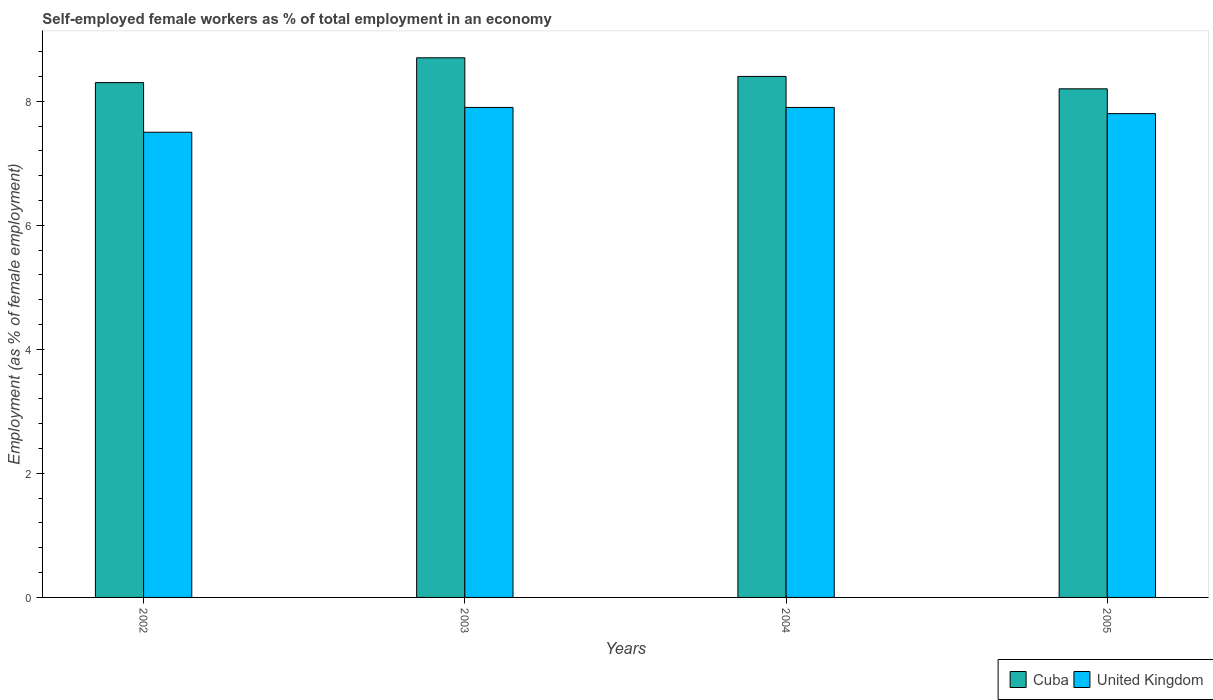How many groups of bars are there?
Your response must be concise. 4. Are the number of bars per tick equal to the number of legend labels?
Your answer should be compact. Yes. Are the number of bars on each tick of the X-axis equal?
Your answer should be compact. Yes. How many bars are there on the 2nd tick from the left?
Your response must be concise. 2. How many bars are there on the 1st tick from the right?
Offer a terse response. 2. In how many cases, is the number of bars for a given year not equal to the number of legend labels?
Give a very brief answer. 0. What is the percentage of self-employed female workers in Cuba in 2005?
Ensure brevity in your answer.  8.2. Across all years, what is the maximum percentage of self-employed female workers in United Kingdom?
Give a very brief answer. 7.9. In which year was the percentage of self-employed female workers in United Kingdom minimum?
Ensure brevity in your answer.  2002. What is the total percentage of self-employed female workers in Cuba in the graph?
Offer a terse response. 33.6. What is the difference between the percentage of self-employed female workers in United Kingdom in 2002 and that in 2005?
Provide a short and direct response. -0.3. What is the difference between the percentage of self-employed female workers in Cuba in 2002 and the percentage of self-employed female workers in United Kingdom in 2004?
Offer a very short reply. 0.4. What is the average percentage of self-employed female workers in Cuba per year?
Offer a very short reply. 8.4. In the year 2005, what is the difference between the percentage of self-employed female workers in United Kingdom and percentage of self-employed female workers in Cuba?
Your response must be concise. -0.4. What is the ratio of the percentage of self-employed female workers in United Kingdom in 2003 to that in 2005?
Keep it short and to the point. 1.01. Is the difference between the percentage of self-employed female workers in United Kingdom in 2004 and 2005 greater than the difference between the percentage of self-employed female workers in Cuba in 2004 and 2005?
Offer a very short reply. No. What is the difference between the highest and the second highest percentage of self-employed female workers in United Kingdom?
Ensure brevity in your answer.  0. Is the sum of the percentage of self-employed female workers in Cuba in 2002 and 2004 greater than the maximum percentage of self-employed female workers in United Kingdom across all years?
Offer a very short reply. Yes. What does the 2nd bar from the right in 2004 represents?
Offer a very short reply. Cuba. Are all the bars in the graph horizontal?
Make the answer very short. No. How many years are there in the graph?
Keep it short and to the point. 4. Are the values on the major ticks of Y-axis written in scientific E-notation?
Offer a very short reply. No. Does the graph contain grids?
Give a very brief answer. No. Where does the legend appear in the graph?
Offer a very short reply. Bottom right. How many legend labels are there?
Offer a very short reply. 2. What is the title of the graph?
Keep it short and to the point. Self-employed female workers as % of total employment in an economy. Does "Antigua and Barbuda" appear as one of the legend labels in the graph?
Your answer should be very brief. No. What is the label or title of the X-axis?
Ensure brevity in your answer.  Years. What is the label or title of the Y-axis?
Offer a terse response. Employment (as % of female employment). What is the Employment (as % of female employment) of Cuba in 2002?
Ensure brevity in your answer.  8.3. What is the Employment (as % of female employment) of Cuba in 2003?
Your response must be concise. 8.7. What is the Employment (as % of female employment) in United Kingdom in 2003?
Offer a very short reply. 7.9. What is the Employment (as % of female employment) in Cuba in 2004?
Provide a succinct answer. 8.4. What is the Employment (as % of female employment) in United Kingdom in 2004?
Your answer should be very brief. 7.9. What is the Employment (as % of female employment) in Cuba in 2005?
Keep it short and to the point. 8.2. What is the Employment (as % of female employment) of United Kingdom in 2005?
Keep it short and to the point. 7.8. Across all years, what is the maximum Employment (as % of female employment) of Cuba?
Your answer should be very brief. 8.7. Across all years, what is the maximum Employment (as % of female employment) of United Kingdom?
Your answer should be very brief. 7.9. Across all years, what is the minimum Employment (as % of female employment) of Cuba?
Provide a succinct answer. 8.2. What is the total Employment (as % of female employment) of Cuba in the graph?
Your response must be concise. 33.6. What is the total Employment (as % of female employment) in United Kingdom in the graph?
Offer a terse response. 31.1. What is the difference between the Employment (as % of female employment) of Cuba in 2002 and that in 2005?
Offer a very short reply. 0.1. What is the difference between the Employment (as % of female employment) in United Kingdom in 2003 and that in 2004?
Give a very brief answer. 0. What is the difference between the Employment (as % of female employment) of United Kingdom in 2003 and that in 2005?
Provide a short and direct response. 0.1. What is the difference between the Employment (as % of female employment) in Cuba in 2002 and the Employment (as % of female employment) in United Kingdom in 2003?
Provide a short and direct response. 0.4. What is the difference between the Employment (as % of female employment) in Cuba in 2002 and the Employment (as % of female employment) in United Kingdom in 2004?
Make the answer very short. 0.4. What is the difference between the Employment (as % of female employment) in Cuba in 2002 and the Employment (as % of female employment) in United Kingdom in 2005?
Give a very brief answer. 0.5. What is the difference between the Employment (as % of female employment) in Cuba in 2003 and the Employment (as % of female employment) in United Kingdom in 2005?
Provide a short and direct response. 0.9. What is the average Employment (as % of female employment) in United Kingdom per year?
Provide a short and direct response. 7.78. In the year 2002, what is the difference between the Employment (as % of female employment) in Cuba and Employment (as % of female employment) in United Kingdom?
Your response must be concise. 0.8. In the year 2005, what is the difference between the Employment (as % of female employment) of Cuba and Employment (as % of female employment) of United Kingdom?
Give a very brief answer. 0.4. What is the ratio of the Employment (as % of female employment) in Cuba in 2002 to that in 2003?
Your answer should be compact. 0.95. What is the ratio of the Employment (as % of female employment) in United Kingdom in 2002 to that in 2003?
Offer a very short reply. 0.95. What is the ratio of the Employment (as % of female employment) in Cuba in 2002 to that in 2004?
Give a very brief answer. 0.99. What is the ratio of the Employment (as % of female employment) of United Kingdom in 2002 to that in 2004?
Give a very brief answer. 0.95. What is the ratio of the Employment (as % of female employment) in Cuba in 2002 to that in 2005?
Offer a terse response. 1.01. What is the ratio of the Employment (as % of female employment) of United Kingdom in 2002 to that in 2005?
Offer a very short reply. 0.96. What is the ratio of the Employment (as % of female employment) of Cuba in 2003 to that in 2004?
Provide a short and direct response. 1.04. What is the ratio of the Employment (as % of female employment) of United Kingdom in 2003 to that in 2004?
Offer a very short reply. 1. What is the ratio of the Employment (as % of female employment) of Cuba in 2003 to that in 2005?
Offer a very short reply. 1.06. What is the ratio of the Employment (as % of female employment) of United Kingdom in 2003 to that in 2005?
Your answer should be very brief. 1.01. What is the ratio of the Employment (as % of female employment) in Cuba in 2004 to that in 2005?
Your answer should be very brief. 1.02. What is the ratio of the Employment (as % of female employment) of United Kingdom in 2004 to that in 2005?
Provide a short and direct response. 1.01. What is the difference between the highest and the second highest Employment (as % of female employment) of Cuba?
Offer a very short reply. 0.3. What is the difference between the highest and the lowest Employment (as % of female employment) in Cuba?
Your answer should be compact. 0.5. What is the difference between the highest and the lowest Employment (as % of female employment) in United Kingdom?
Your response must be concise. 0.4. 